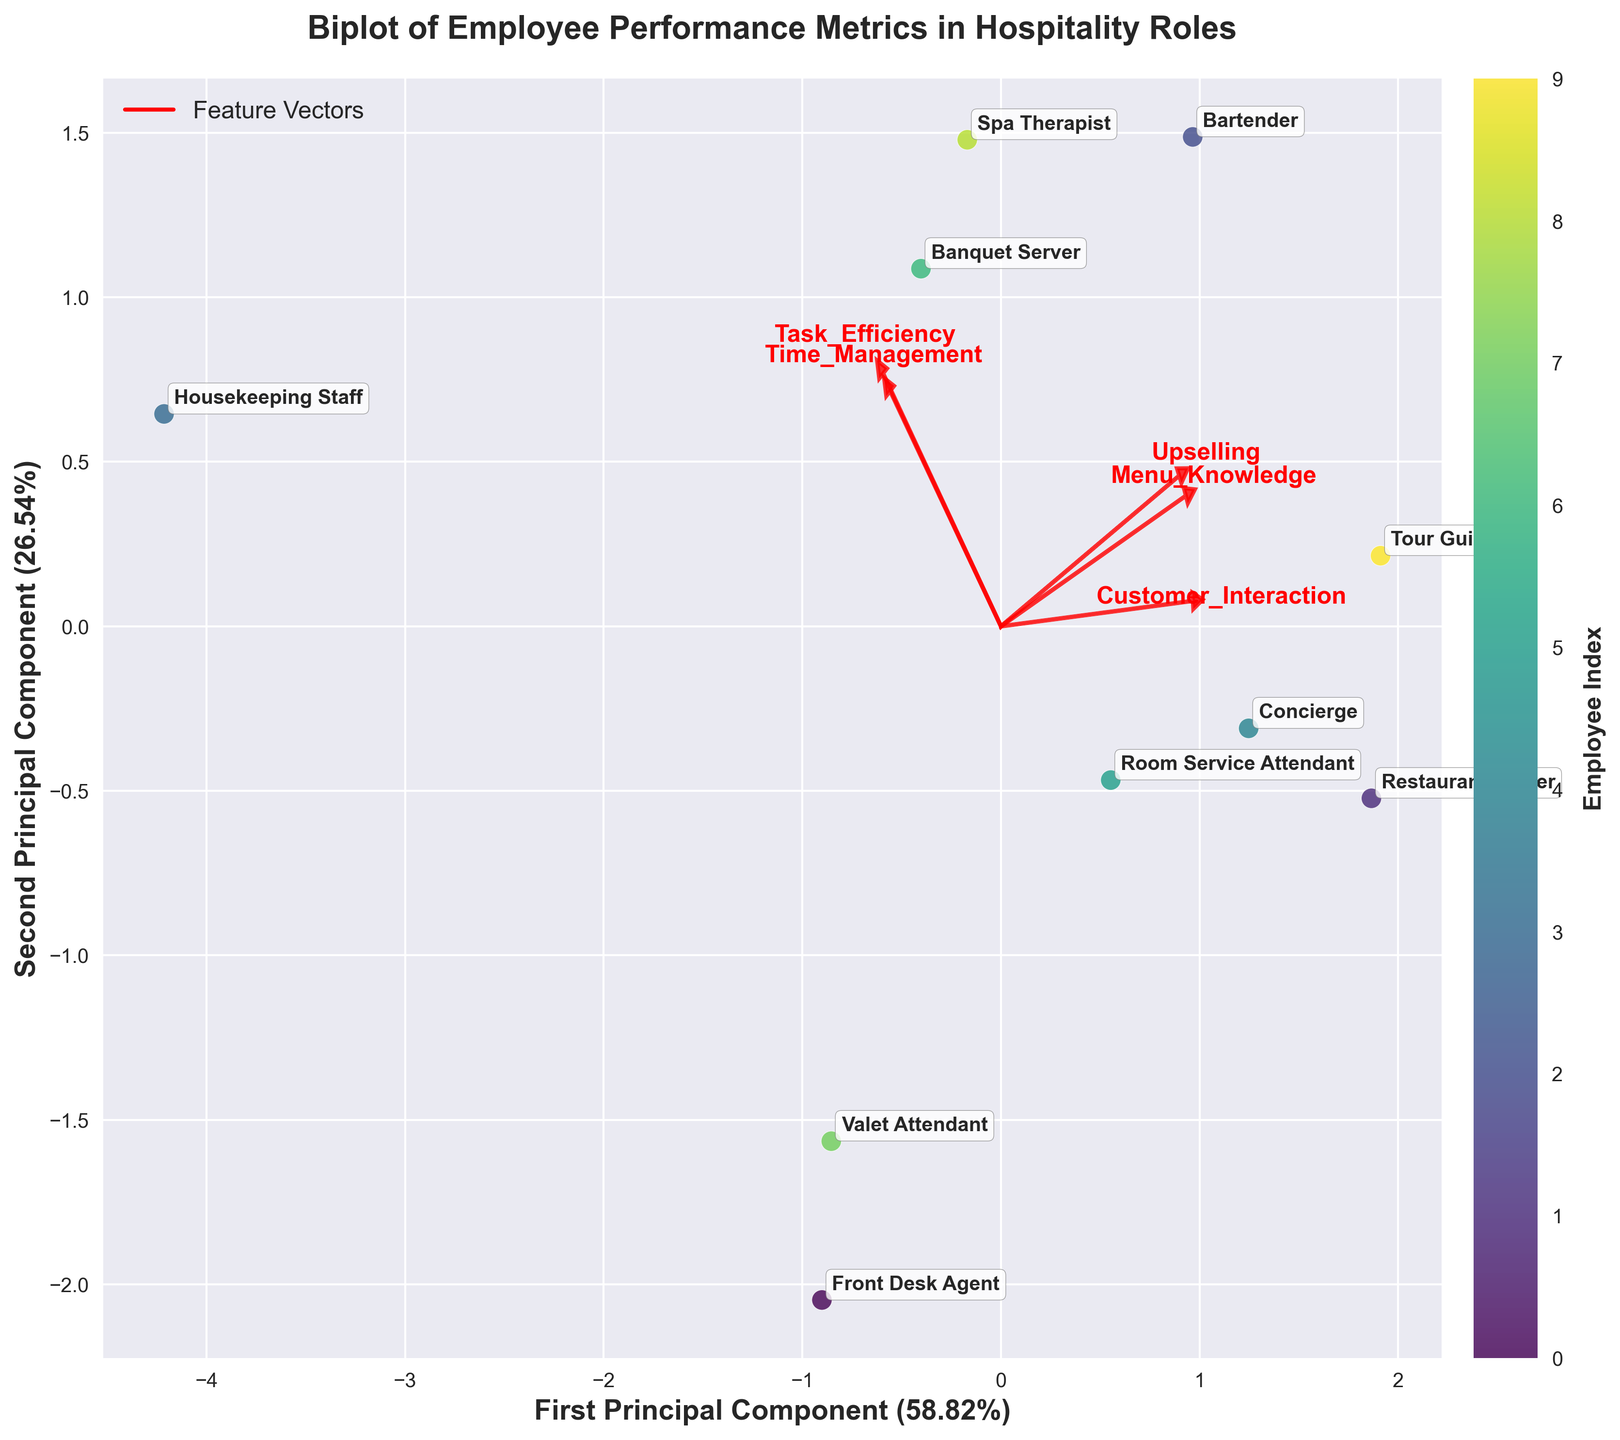How many hospitality roles are represented in the biplot? There are data points that correspond to hospitality roles labeled on the biplot. Counting these unique labels corresponds to the number of roles.
Answer: 10 Which employee role has the highest customer interaction score? We need to look at the position of the employee roles along the direction of the Customer Interaction vector in the biplot. The role furthest along this vector has the highest score.
Answer: Concierge What is the relationship between Task Efficiency and Time Management for the Restaurant Server compared to Housekeeping Staff? By comparing the relative positions of the Restaurant Server and Housekeeping Staff along the directions of Task Efficiency and Time Management vectors, we can assess which has higher scores for each aspect. The Restaurant Server shows scores of Task Efficiency closer to Housekeeping Staff while the latter has greater Time Management scores.
Answer: Restaurant Server: lower Time Management, similar Task Efficiency Which feature vector appears to be most aligned with the first principal component? The feature vector whose arrow falls closest to the direction of the first principal component axis is most aligned with the first principal component.
Answer: Customer Interaction Which role appears furthest from the origin of the biplot? The role that has the maximum distance from the origin (0,0) on the plot is the furthest. This can be assessed visually.
Answer: Spa Therapist How do Bartender and Banquet Server compare in terms of Upselling and Menu Knowledge? By examining their positions relative to Upselling and Menu Knowledge vectors, we can compare their scores. Bartender is higher in Upselling, while Banquet Server is moderately close to Menu Knowledge.
Answer: Bartender: higher in Upselling Which two roles are most similar in their performance metrics based on the biplot? We identify roles that are closest to each other on the biplot as having similar performance metrics.
Answer: Room Service Attendant and Banquet Server What percentage of the variance is explained by the first and second principal components combined? Adding up the percentages explained by the first and second principal components, as labeled on their respective axes.
Answer: 62.11% Which role is characterized by high scores in both Customer Interaction and Time Management? This role will be positioned far along the vectors representing Customer Interaction and Time Management.
Answer: Concierge 